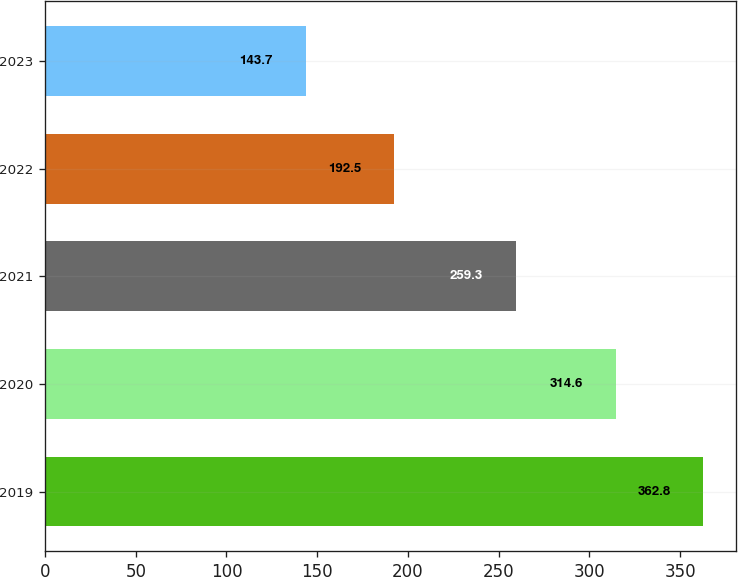Convert chart. <chart><loc_0><loc_0><loc_500><loc_500><bar_chart><fcel>2019<fcel>2020<fcel>2021<fcel>2022<fcel>2023<nl><fcel>362.8<fcel>314.6<fcel>259.3<fcel>192.5<fcel>143.7<nl></chart> 